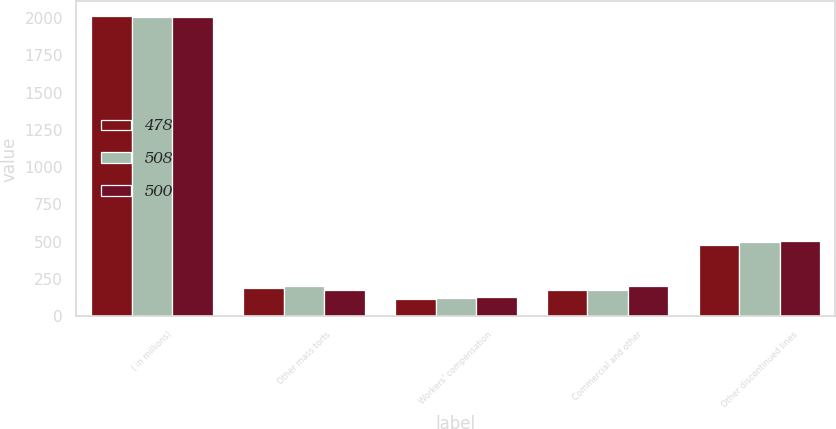<chart> <loc_0><loc_0><loc_500><loc_500><stacked_bar_chart><ecel><fcel>( in millions)<fcel>Other mass torts<fcel>Workers' compensation<fcel>Commercial and other<fcel>Other discontinued lines<nl><fcel>478<fcel>2010<fcel>188<fcel>116<fcel>174<fcel>478<nl><fcel>508<fcel>2009<fcel>201<fcel>122<fcel>177<fcel>500<nl><fcel>500<fcel>2008<fcel>177<fcel>130<fcel>201<fcel>508<nl></chart> 